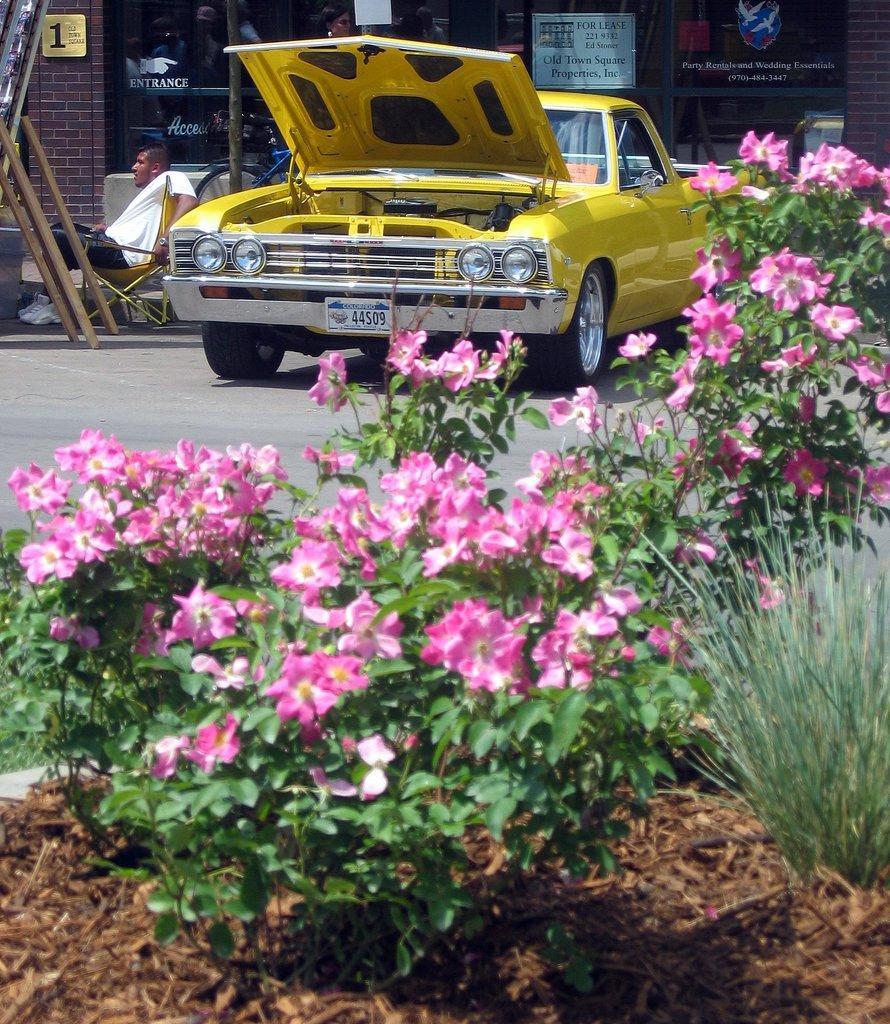In one or two sentences, can you explain what this image depicts? In this image we can see plants, flowers, wooden sticks, and a board. There is a car on the road. Here we can see a person sitting on the chair. In the background we can see a building, glass, and posters. 